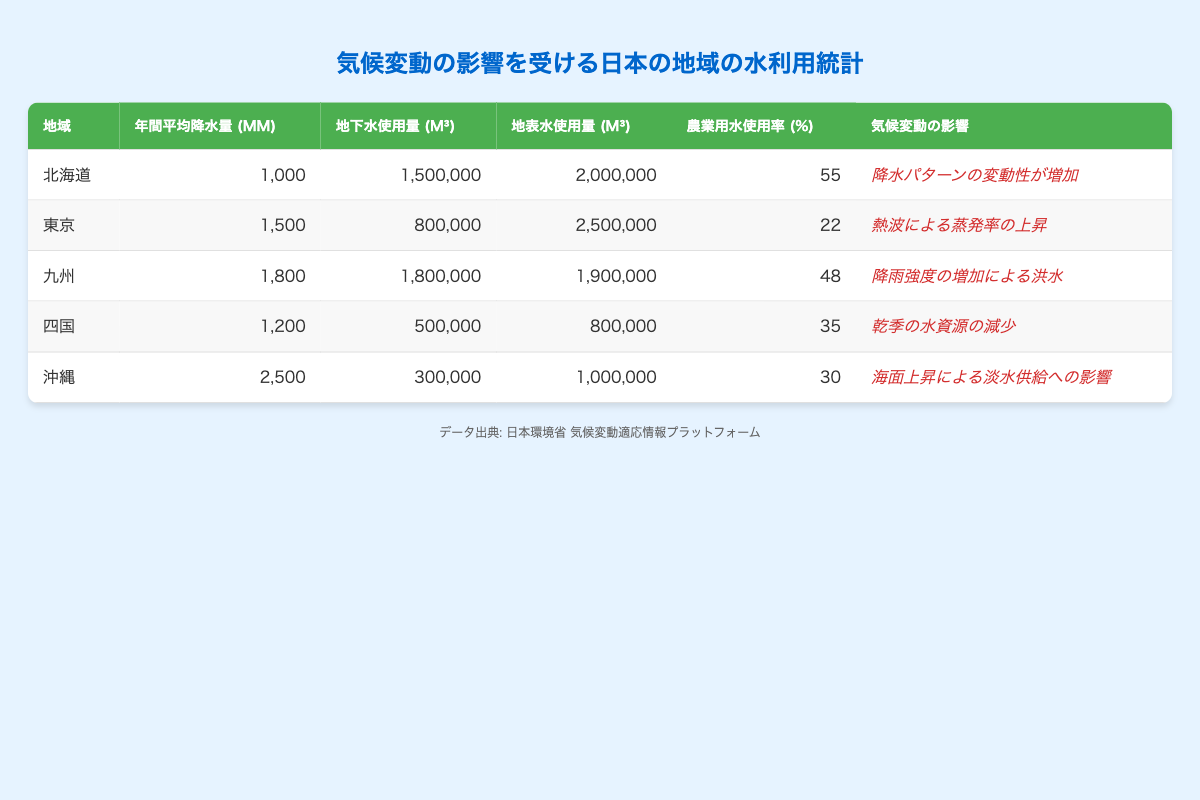What is the average annual rainfall in Kyushu? The table shows that Kyushu has an average annual rainfall of 1800 mm.
Answer: 1800 mm Which region has the highest groundwater usage? By reviewing the groundwater usage column, we find that Kyushu has the highest usage at 1800000 m³.
Answer: Kyushu What percentage of agricultural water use is highest in the regions listed? Comparing the agricultural water use percentages, Hokkaido has the highest at 55%.
Answer: 55% What is the total groundwater usage across all regions? To find this, we sum the groundwater usages: 1500000 + 800000 + 1800000 + 500000 + 300000 = 4700000 m³.
Answer: 4700000 m³ Is the average annual rainfall in Shikoku greater than that in Hokkaido? Looking at the average annual rainfall values, Shikoku has 1200 mm while Hokkaido has 1000 mm. Since 1200 mm is greater than 1000 mm, the statement is true.
Answer: Yes What is the difference in surface water usage between Tokyo and Okinawa? The surface water usage for Tokyo is 2500000 m³ and for Okinawa is 1000000 m³. The difference is 2500000 - 1000000 = 1500000 m³.
Answer: 1500000 m³ Which region is affected by increased variability in precipitation patterns? Referring to the climate change impact column, Hokkaido is indicated to be affected by increased variability in precipitation patterns.
Answer: Hokkaido What is the total agricultural water use percentage across all regions, and what is the average? The total agricultural water use percentage is calculated as: 55 + 22 + 48 + 35 + 30 = 190%. The average is 190% / 5 = 38%.
Answer: 38% Is it true that Okinawa has the lowest groundwater usage among the regions? By examining the groundwater usage, Okinawa's 300000 m³ is the lowest compared to the values for the other regions. Therefore, the statement is true.
Answer: Yes 